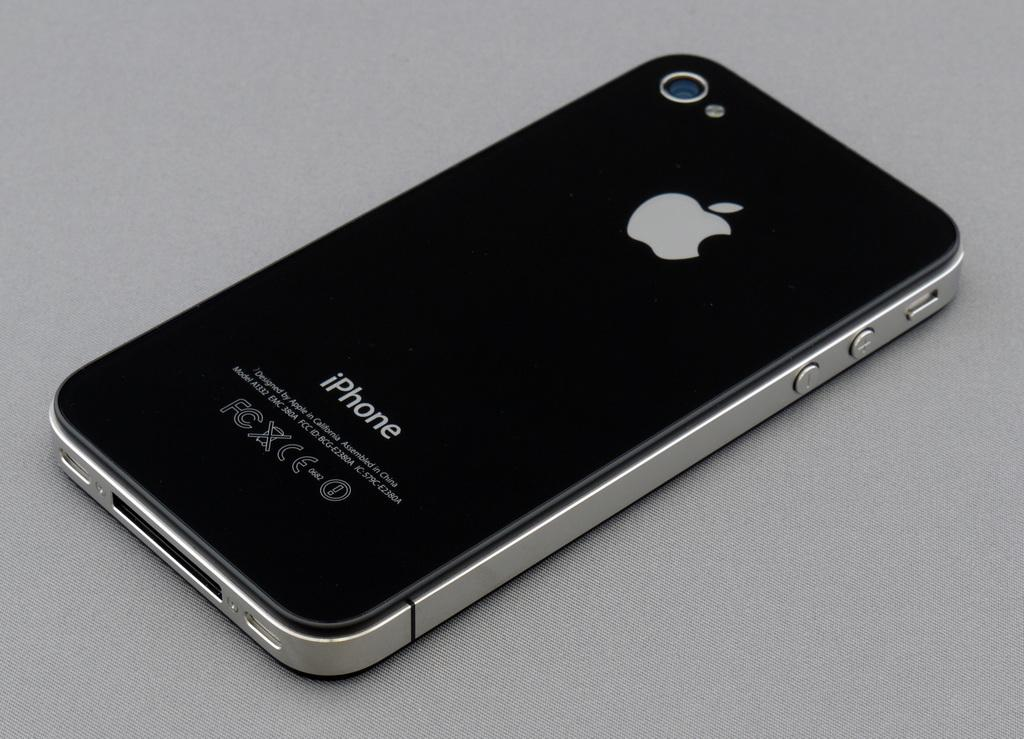<image>
Share a concise interpretation of the image provided. An Apple brand phone with an iPhone label on the back. 